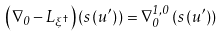<formula> <loc_0><loc_0><loc_500><loc_500>\left ( \nabla _ { 0 } - L _ { \xi ^ { \dagger } } \right ) \left ( s \left ( u ^ { \prime } \right ) \right ) = \nabla _ { 0 } ^ { 1 , 0 } \left ( s \left ( u ^ { \prime } \right ) \right )</formula> 